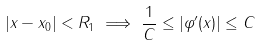Convert formula to latex. <formula><loc_0><loc_0><loc_500><loc_500>| x - x _ { 0 } | < R _ { 1 } \implies \frac { 1 } { C } \leq | \varphi ^ { \prime } ( x ) | \leq C</formula> 